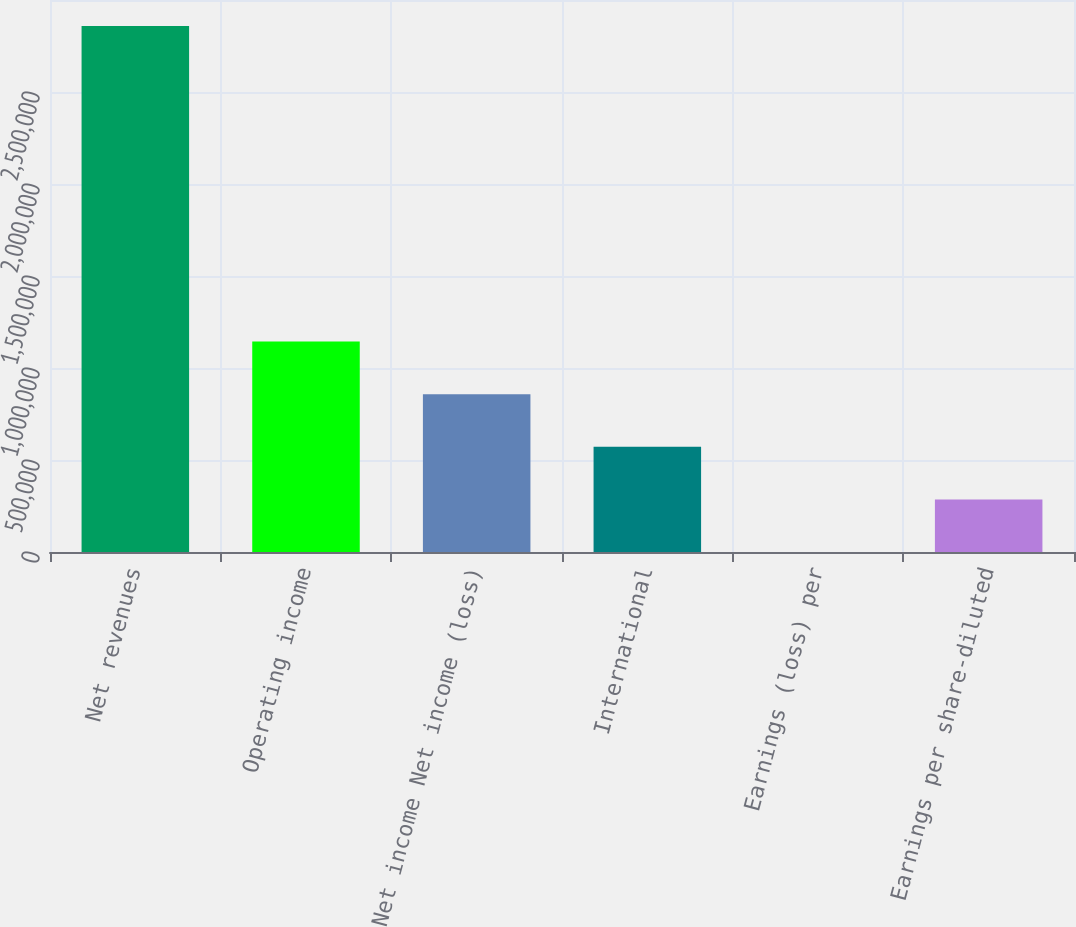<chart> <loc_0><loc_0><loc_500><loc_500><bar_chart><fcel>Net revenues<fcel>Operating income<fcel>Net income Net income (loss)<fcel>International<fcel>Earnings (loss) per<fcel>Earnings per share-diluted<nl><fcel>2.8587e+06<fcel>1.14348e+06<fcel>857609<fcel>571739<fcel>0.21<fcel>285870<nl></chart> 